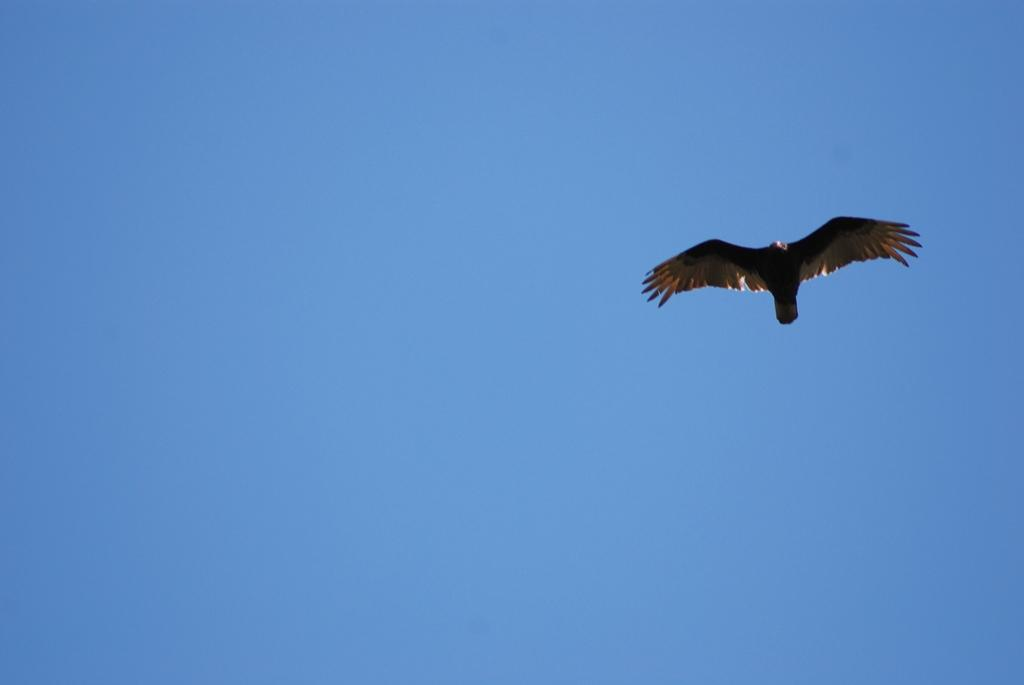Where was the image taken? The image was taken outdoors. What can be seen in the middle of the image? The sky is visible in the middle of the image. What is happening in the sky on the right side of the image? A bird is flying in the sky on the right side of the image. What type of cart is being pulled by the animal in the image? There is no cart or animal present in the image; it only features a bird flying in the sky. 